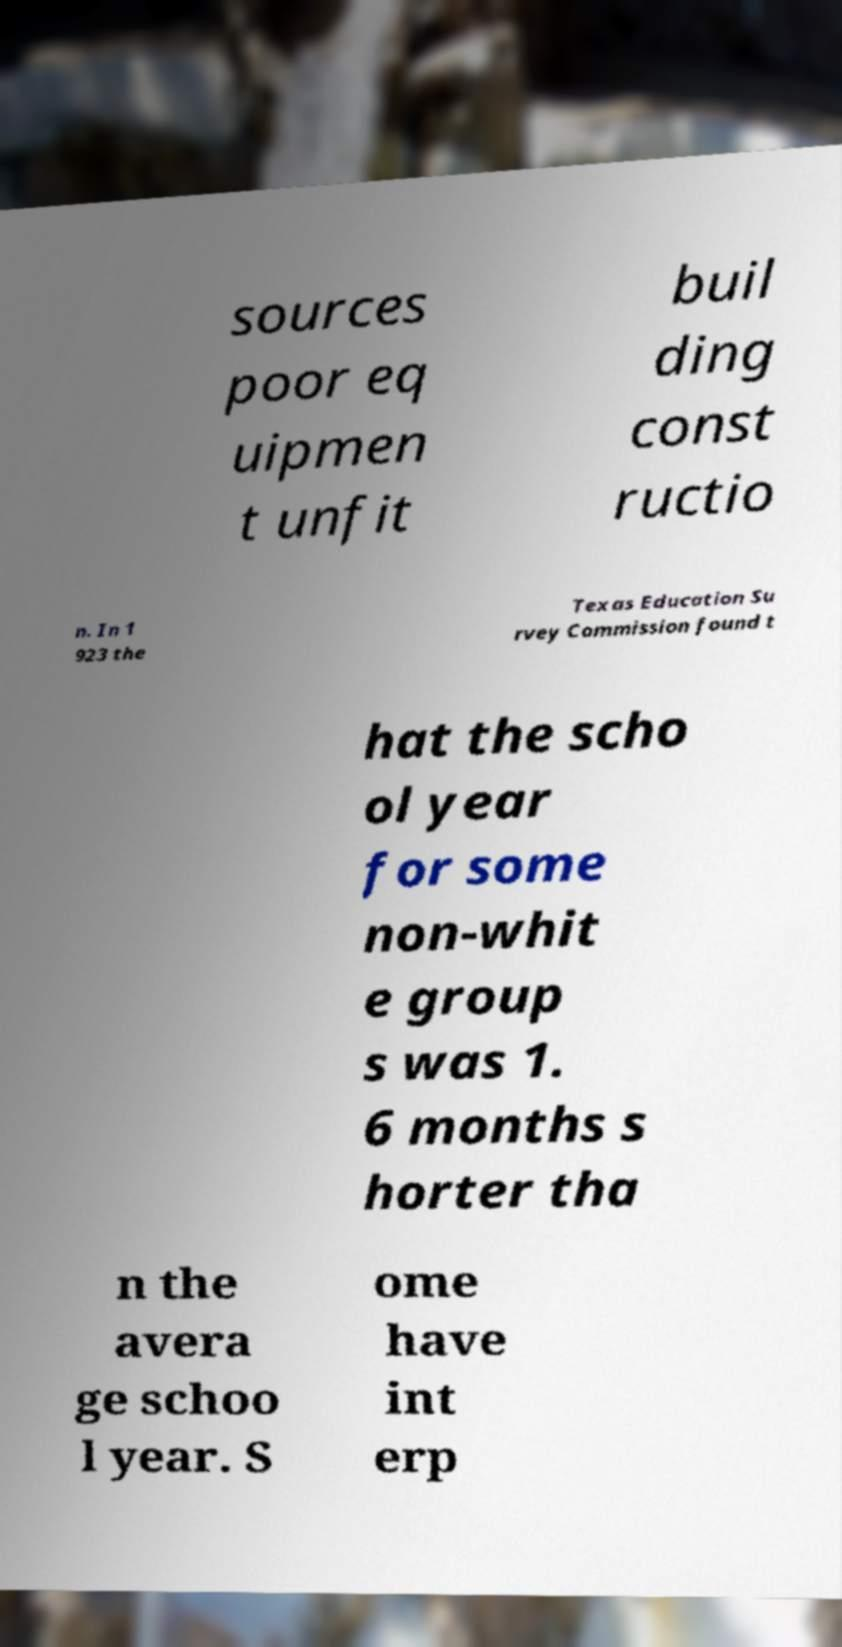What messages or text are displayed in this image? I need them in a readable, typed format. sources poor eq uipmen t unfit buil ding const ructio n. In 1 923 the Texas Education Su rvey Commission found t hat the scho ol year for some non-whit e group s was 1. 6 months s horter tha n the avera ge schoo l year. S ome have int erp 